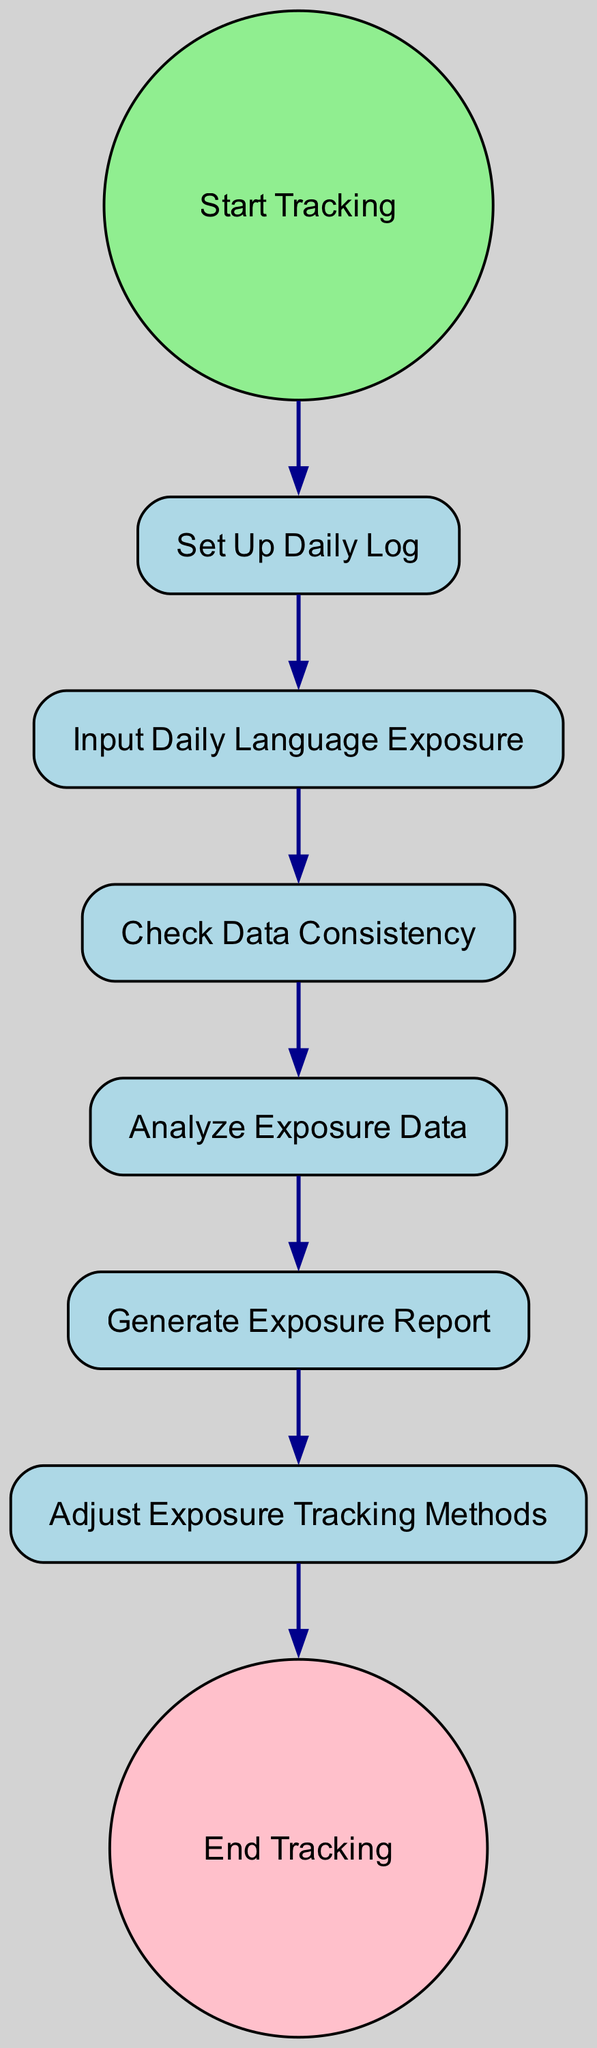What is the first activity in the diagram? The diagram begins with the 'Start Tracking' event, which is depicted as the starting point, leading to the 'Set Up Daily Log' activity. Therefore, the first activity following the start event is 'Set Up Daily Log'.
Answer: Set Up Daily Log How many nodes are in the diagram? The diagram consists of eight nodes, which include the start event, end event, and six activities in between.
Answer: Eight Which activity comes after 'Input Daily Language Exposure'? Following 'Input Daily Language Exposure', the next activity is 'Check Data Consistency', as indicated by the directed edge connecting the two nodes in the diagram.
Answer: Check Data Consistency What happens after generating the exposure report? After 'Generate Exposure Report', the next step in the diagram is 'Adjust Exposure Tracking Methods', showing the flow of activities in the tracking process.
Answer: Adjust Exposure Tracking Methods What is the last event in this activity diagram? The last event depicted in the diagram is 'End Tracking', which concludes the activity sequence after all prior steps have been completed.
Answer: End Tracking How many transitions are in the diagram? The diagram features six transitions, which represent the pathways between the nodes, connecting each activity from start to end.
Answer: Six What is the relationship between 'Analyze Exposure Data' and 'Check Data Consistency'? 'Analyze Exposure Data' follows 'Check Data Consistency'; this indicates a sequential relationship where consistency must be checked before analysis.
Answer: Sequential relationship Which activities are performed before adjusting the methods? Before 'Adjust Exposure Tracking Methods', the activities performed are 'Generate Exposure Report' and 'Analyze Exposure Data', which are essential precursors in the process.
Answer: Generate Exposure Report and Analyze Exposure Data What type of diagram is this? This diagram is an Activity Diagram, which models the sequence of activities involved in tracking daily language exposure for multilingual children.
Answer: Activity Diagram 